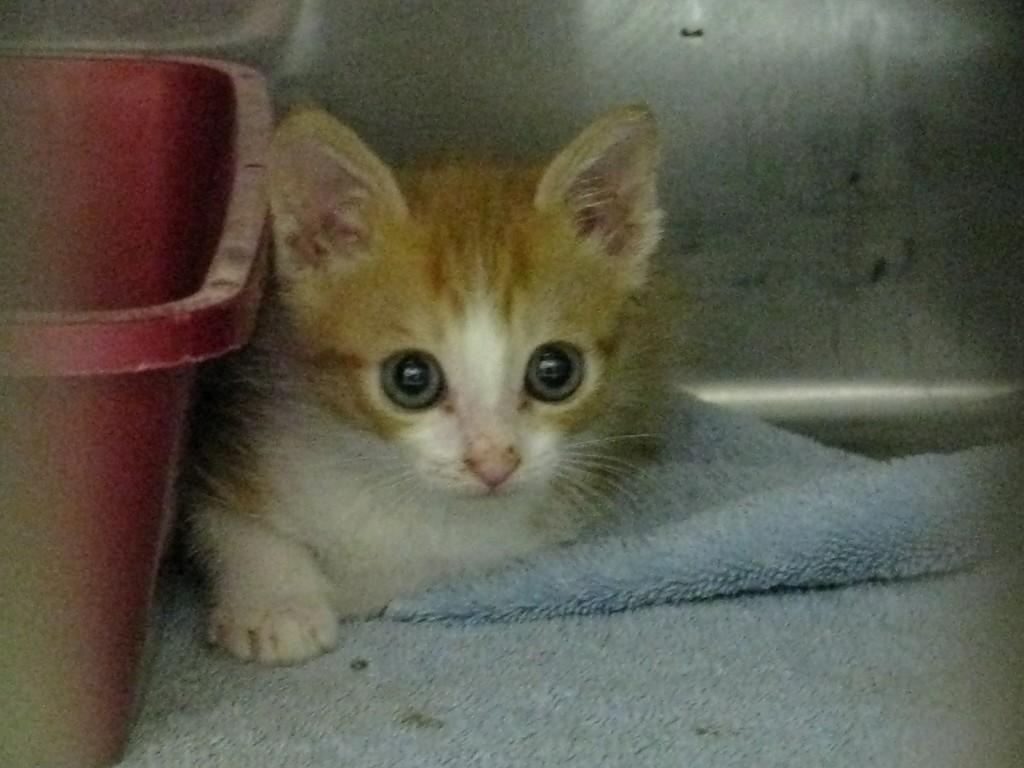Can you describe this image briefly? In this picture there is a cat in the center of the image, on a mat and there is a tub on the left side of the image. 